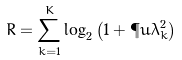Convert formula to latex. <formula><loc_0><loc_0><loc_500><loc_500>R = \sum _ { k = 1 } ^ { K } \log _ { 2 } \left ( 1 + { \P u } \lambda _ { k } ^ { 2 } \right )</formula> 